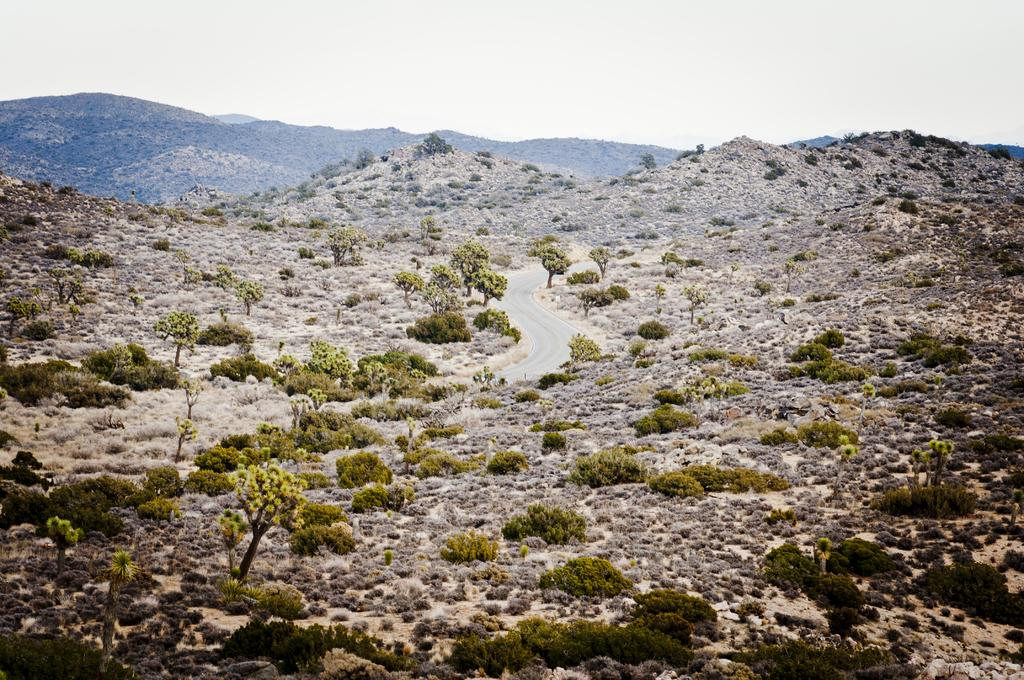What type of vegetation can be seen at the bottom of the image? There are trees, plants, and grass at the bottom of the image. What type of terrain is present at the bottom of the image? There is land at the bottom of the image. What can be seen at the top of the image? There are hills, a road, and the sky visible at the top of the image. Can you tell me where the fan is located in the image? There is no fan present in the image. Is there a book visible on the road at the top of the image? There is no book visible in the image; only hills, a road, and the sky are present at the top. 